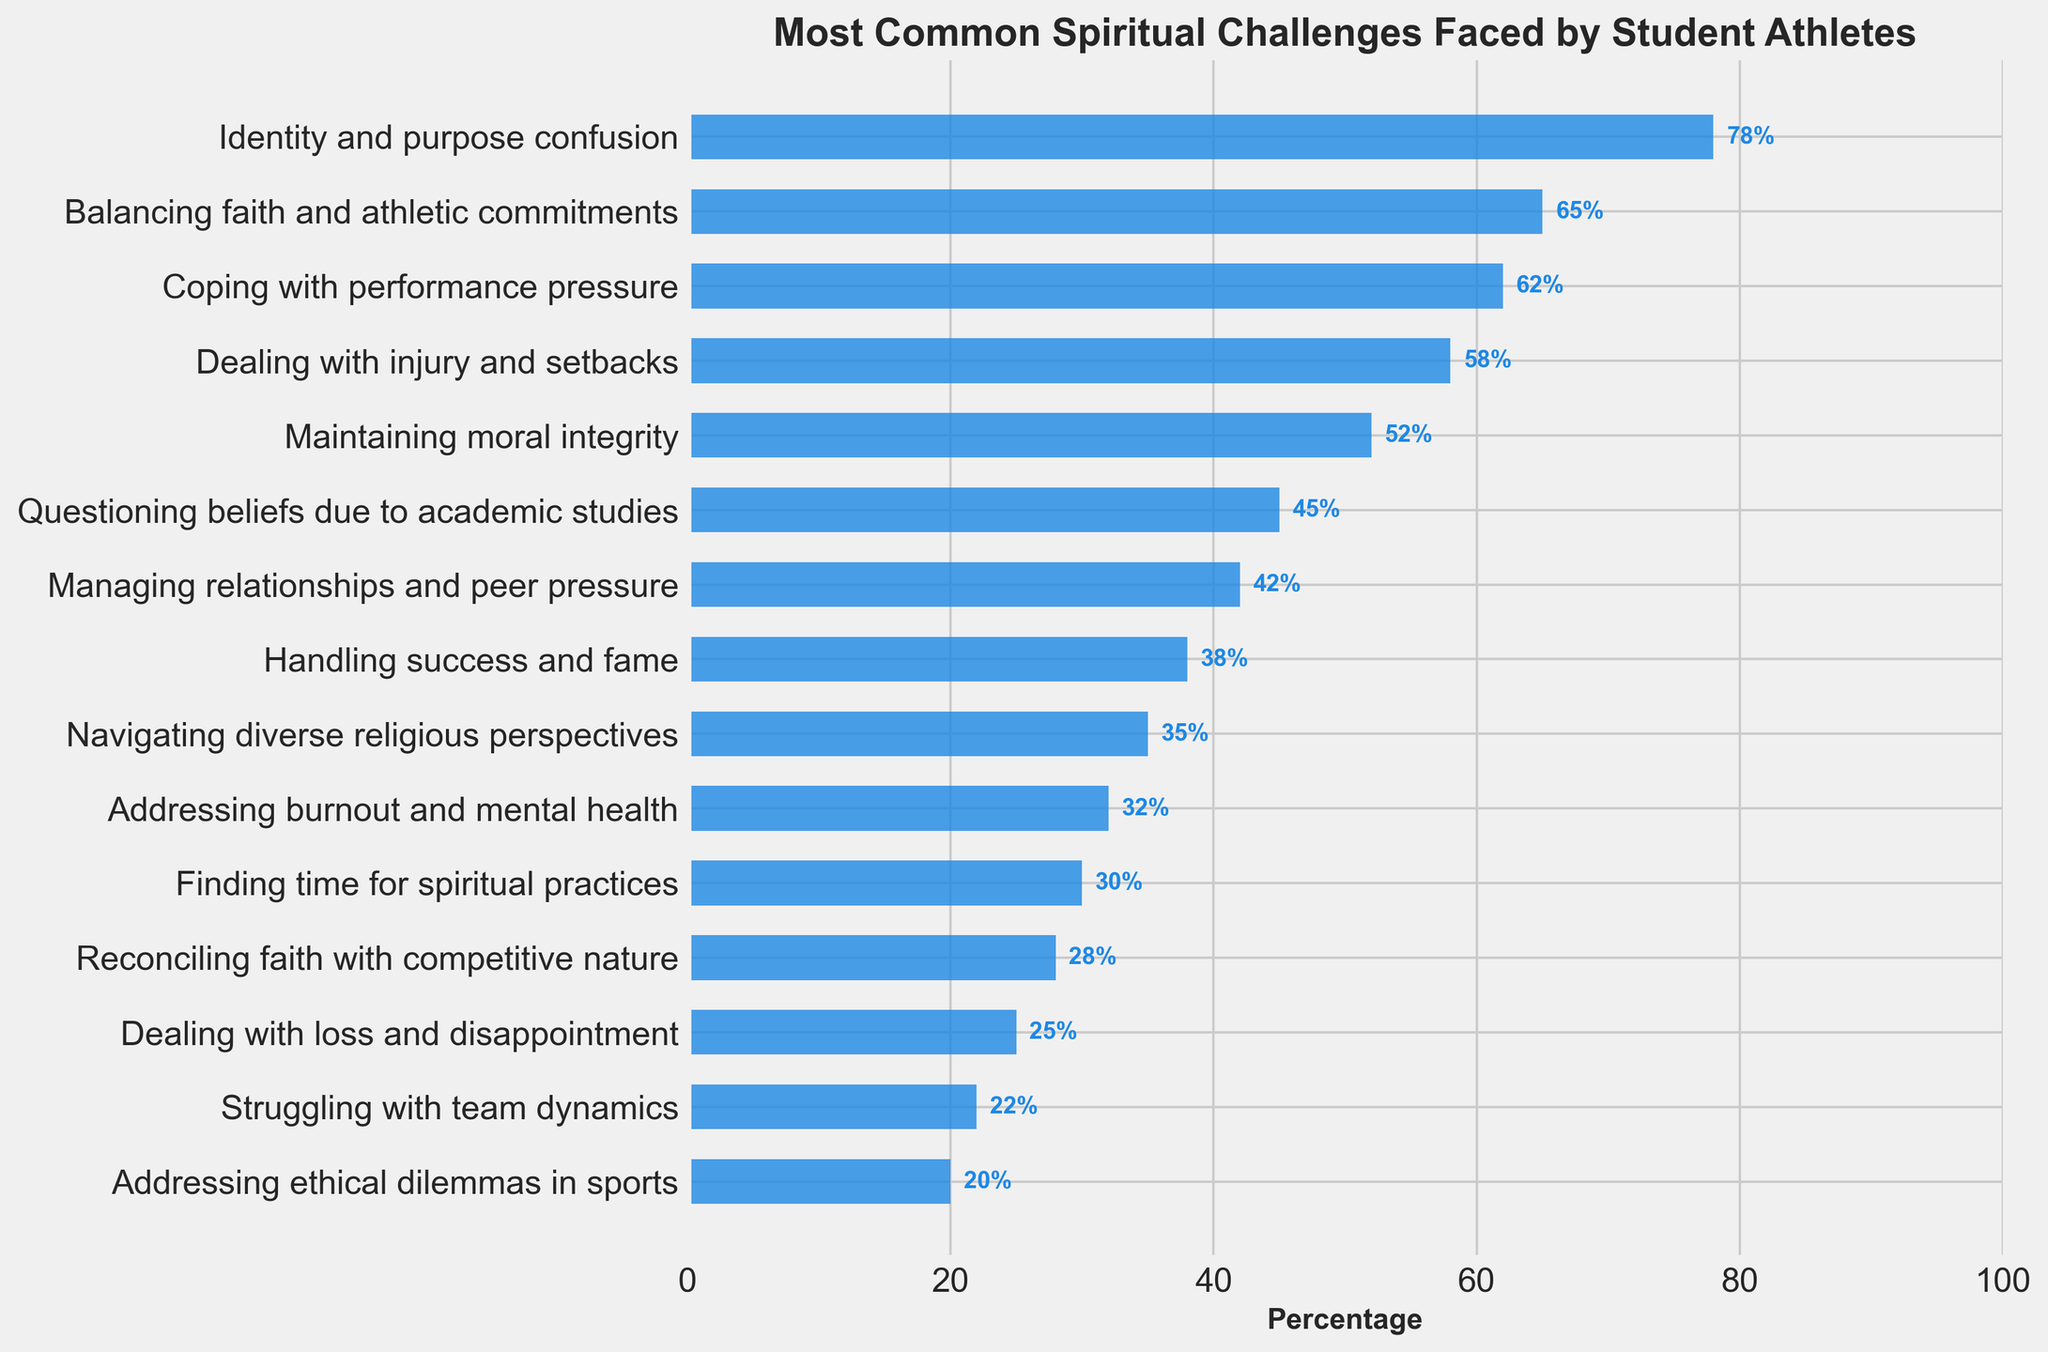Which spiritual challenge has the highest percentage among student athletes? The figure shows that "Identity and purpose confusion" is the tallest bar, indicating the highest percentage of student athletes facing this challenge.
Answer: Identity and purpose confusion Which spiritual challenge has the lowest percentage? The shortest bar represents "Addressing ethical dilemmas in sports," indicating this challenge has the lowest percentage among student athletes.
Answer: Addressing ethical dilemmas in sports How much higher is the percentage for "Coping with performance pressure" compared to "Finding time for spiritual practices"? The percentage for "Coping with performance pressure" is 62%, and for "Finding time for spiritual practices," it is 30%. Subtracting these gives 62% - 30% = 32%.
Answer: 32% What is the sum of percentages for "Balancing faith and athletic commitments" and "Maintaining moral integrity"? The percentages are 65% and 52%, respectively. Adding them together, we get 65% + 52% = 117%.
Answer: 117% Which challenge has a higher percentage, "Questioning beliefs due to academic studies" or "Handling success and fame"? "Questioning beliefs due to academic studies" has a higher percentage of 45%, compared to "Handling success and fame" which has 38%.
Answer: Questioning beliefs due to academic studies What is the difference in percentage between the challenges "Handling success and fame" and "Navigating diverse religious perspectives"? The percentage for "Handling success and fame" is 38%, and for "Navigating diverse religious perspectives," it is 35%. The difference is 38% - 35% = 3%.
Answer: 3% Which spiritual challenges have a percentage of 35% or higher but less than 50%? Checking the figure, the challenges with percentages between 35% and 50% are "Questioning beliefs due to academic studies" (45%) and "Managing relationships and peer pressure" (42%).
Answer: Questioning beliefs due to academic studies, Managing relationships and peer pressure How many spiritual challenges have a percentage of 50% or higher? The challenges with percentages of 50% or higher are "Identity and purpose confusion" (78%), "Balancing faith and athletic commitments" (65%), "Coping with performance pressure" (62%), "Dealing with injury and setbacks" (58%), and "Maintaining moral integrity" (52%). Counting these gives us 5 challenges.
Answer: 5 Identify the three least common spiritual challenges and provide their combined percentage. The three challenges with the smallest percentages are "Struggling with team dynamics" (22%), "Addressing ethical dilemmas in sports" (20%), and "Dealing with loss and disappointment" (25%). Their combined percentage is 22% + 20% + 25% = 67%.
Answer: 67% Compare the percentages for "Navigating diverse religious perspectives" and "Finding time for spiritual practices." Which one is greater and by how much? "Navigating diverse religious perspectives" has a percentage of 35%, and "Finding time for spiritual practices" has 30%. The difference is 35% - 30% = 5%, with "Navigating diverse religious perspectives" being greater.
Answer: Navigating diverse religious perspectives, 5% 